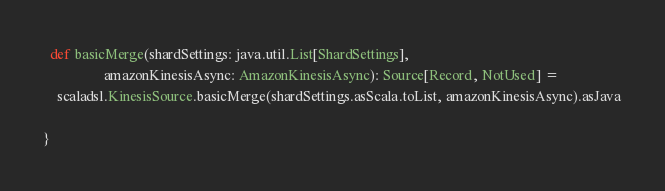Convert code to text. <code><loc_0><loc_0><loc_500><loc_500><_Scala_>  def basicMerge(shardSettings: java.util.List[ShardSettings],
                 amazonKinesisAsync: AmazonKinesisAsync): Source[Record, NotUsed] =
    scaladsl.KinesisSource.basicMerge(shardSettings.asScala.toList, amazonKinesisAsync).asJava

}
</code> 